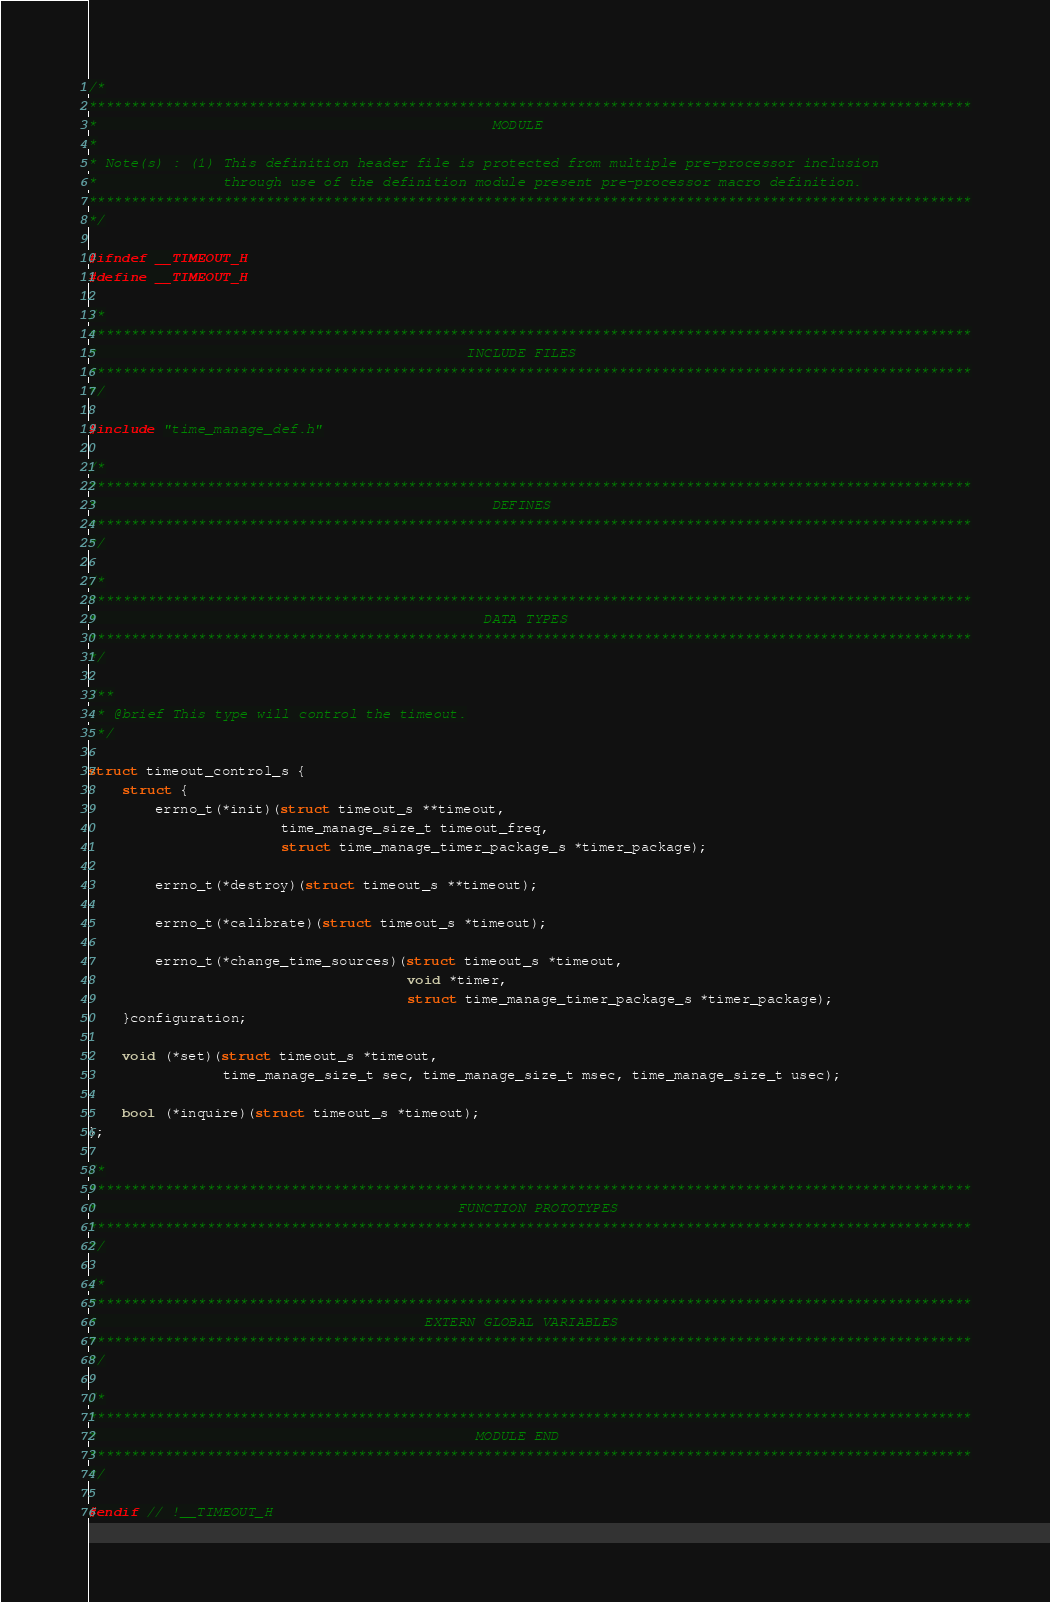Convert code to text. <code><loc_0><loc_0><loc_500><loc_500><_C_>/*
*********************************************************************************************************
*                                               MODULE
*
* Note(s) : (1) This definition header file is protected from multiple pre-processor inclusion
*               through use of the definition module present pre-processor macro definition.
*********************************************************************************************************
*/

#ifndef __TIMEOUT_H
#define __TIMEOUT_H

/*
*********************************************************************************************************
*                                            INCLUDE FILES
*********************************************************************************************************
*/

#include "time_manage_def.h"

/*
*********************************************************************************************************
*									            DEFINES
*********************************************************************************************************
*/

/*
*********************************************************************************************************
*									           DATA TYPES
*********************************************************************************************************
*/

/**
 * @brief This type will control the timeout.
 */

struct timeout_control_s {
	struct {
		errno_t(*init)(struct timeout_s **timeout,
					   time_manage_size_t timeout_freq,
					   struct time_manage_timer_package_s *timer_package);

		errno_t(*destroy)(struct timeout_s **timeout);

		errno_t(*calibrate)(struct timeout_s *timeout);

		errno_t(*change_time_sources)(struct timeout_s *timeout,
									  void *timer,
									  struct time_manage_timer_package_s *timer_package);
	}configuration;

	void (*set)(struct timeout_s *timeout,
				time_manage_size_t sec, time_manage_size_t msec, time_manage_size_t usec);

	bool (*inquire)(struct timeout_s *timeout);
};

/*
*********************************************************************************************************
*								            FUNCTION PROTOTYPES
*********************************************************************************************************
*/

/*
*********************************************************************************************************
*                                       EXTERN GLOBAL VARIABLES
*********************************************************************************************************
*/

/*
*********************************************************************************************************
*                                             MODULE END
*********************************************************************************************************
*/

#endif // !__TIMEOUT_H</code> 